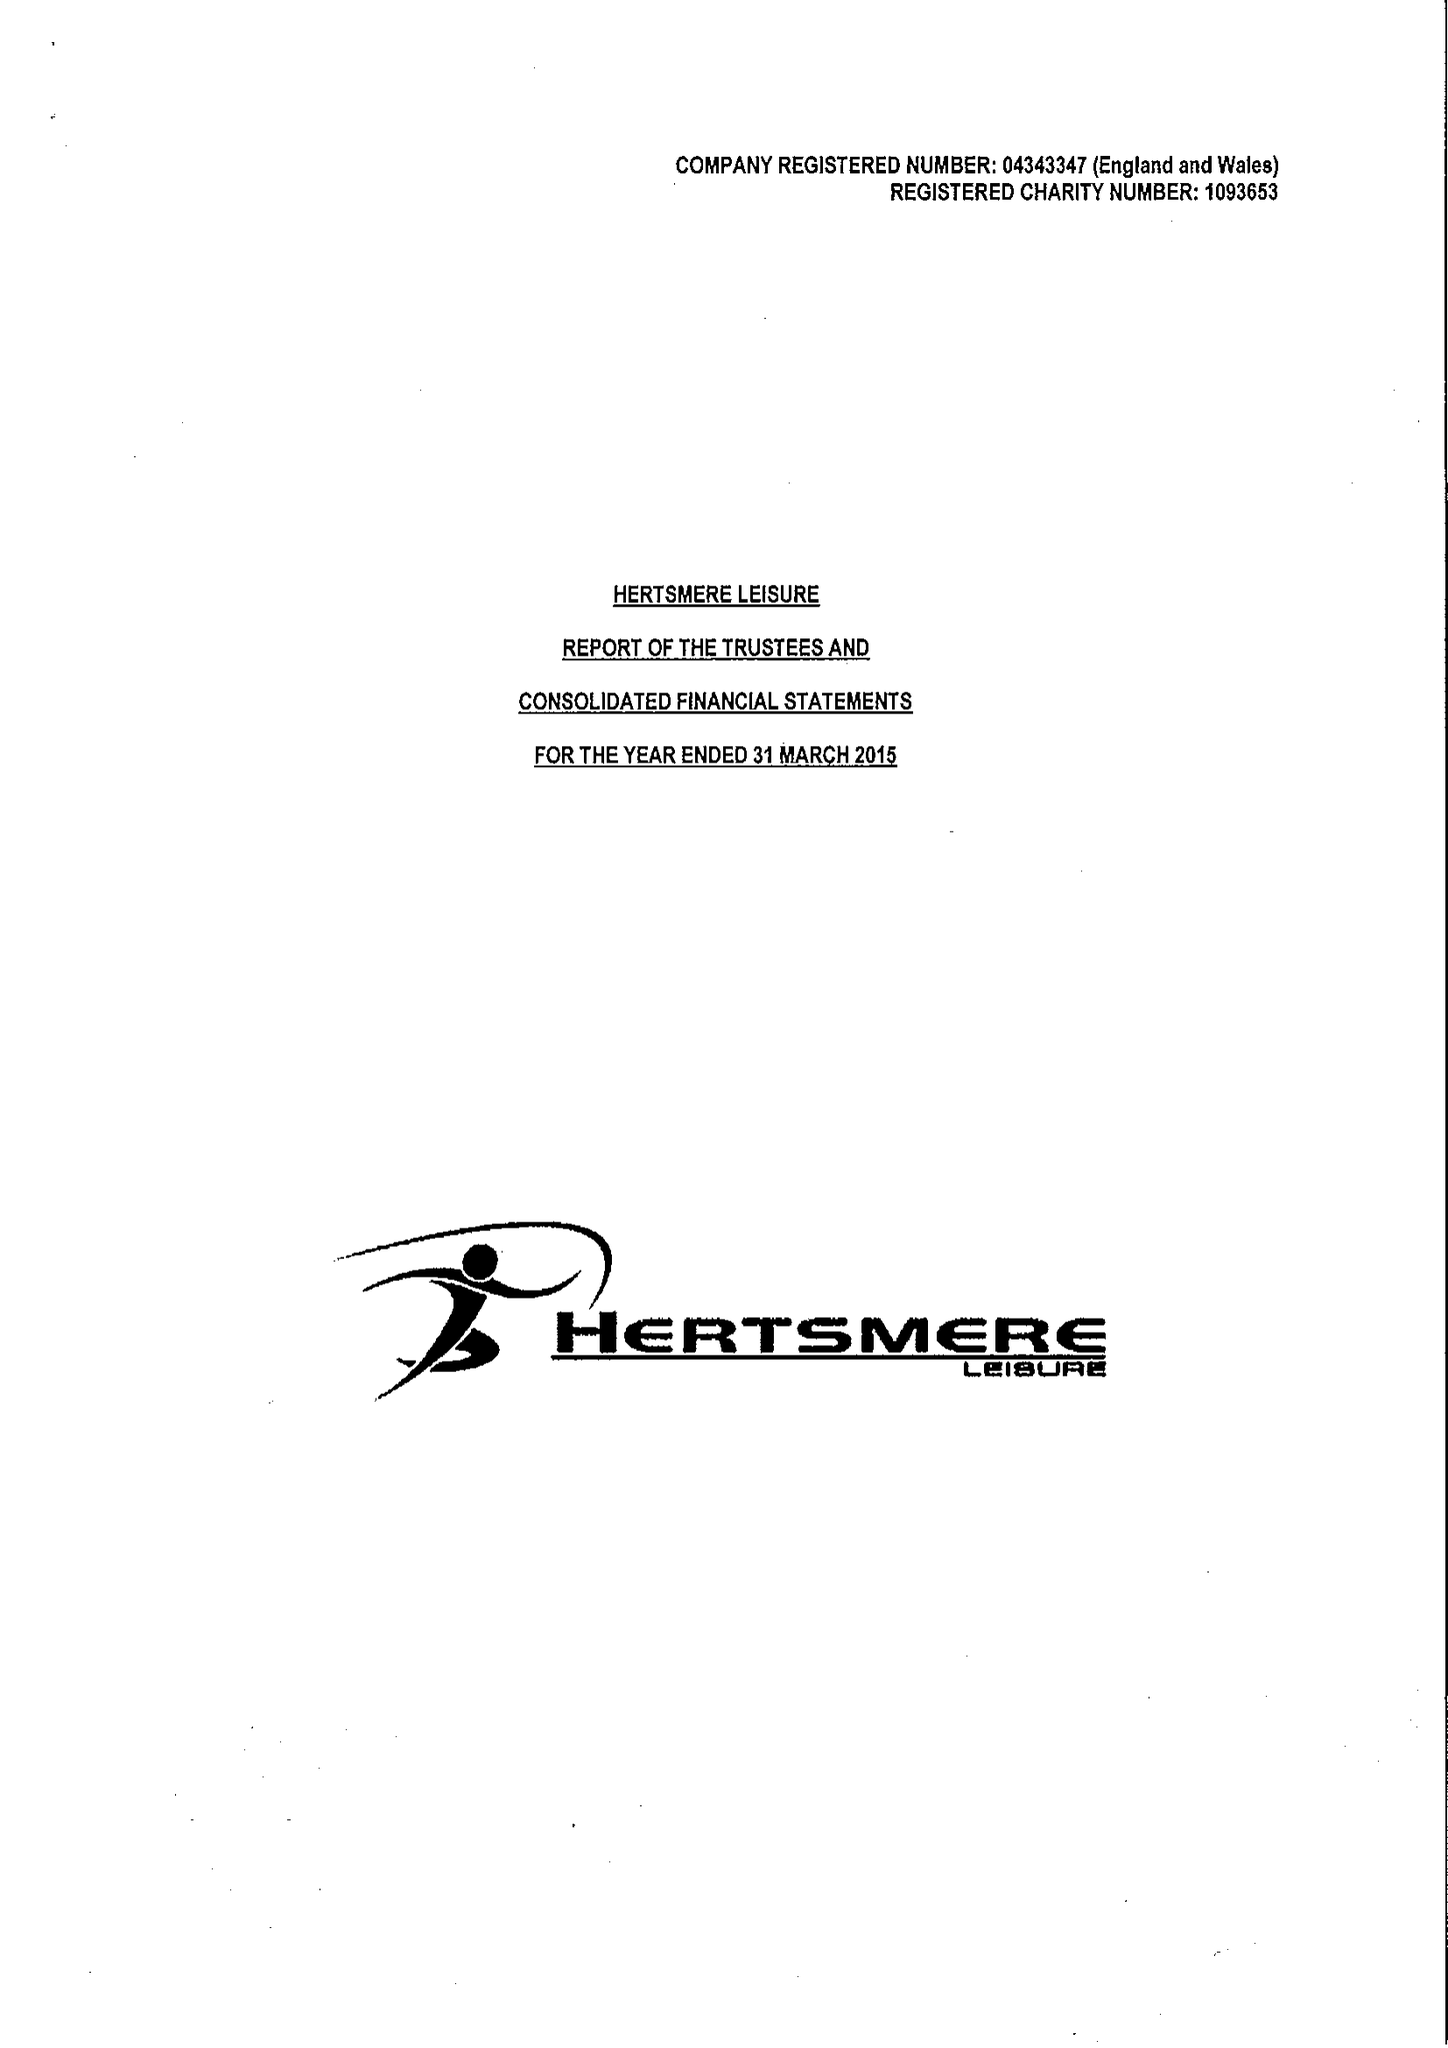What is the value for the address__postcode?
Answer the question using a single word or phrase. WD6 1JY 